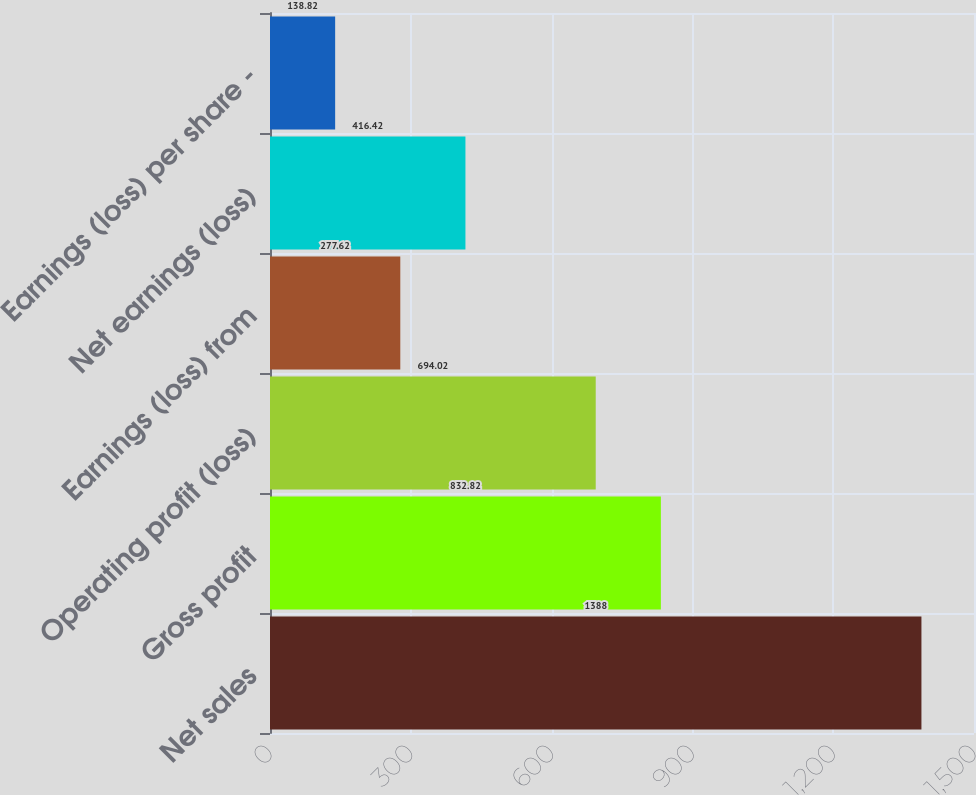Convert chart. <chart><loc_0><loc_0><loc_500><loc_500><bar_chart><fcel>Net sales<fcel>Gross profit<fcel>Operating profit (loss)<fcel>Earnings (loss) from<fcel>Net earnings (loss)<fcel>Earnings (loss) per share -<nl><fcel>1388<fcel>832.82<fcel>694.02<fcel>277.62<fcel>416.42<fcel>138.82<nl></chart> 